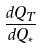Convert formula to latex. <formula><loc_0><loc_0><loc_500><loc_500>\frac { d Q _ { T } } { d Q _ { * } }</formula> 